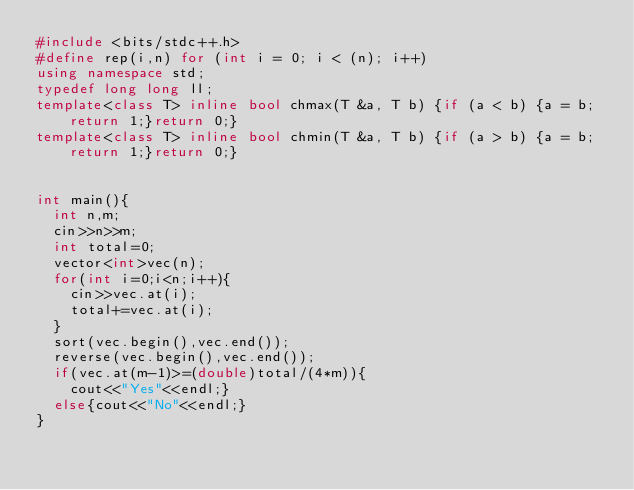Convert code to text. <code><loc_0><loc_0><loc_500><loc_500><_C++_>#include <bits/stdc++.h>
#define rep(i,n) for (int i = 0; i < (n); i++)
using namespace std;
typedef long long ll;
template<class T> inline bool chmax(T &a, T b) {if (a < b) {a = b;return 1;}return 0;}
template<class T> inline bool chmin(T &a, T b) {if (a > b) {a = b;return 1;}return 0;}


int main(){
  int n,m;
  cin>>n>>m;
  int total=0;
  vector<int>vec(n);
  for(int i=0;i<n;i++){
    cin>>vec.at(i);
    total+=vec.at(i);
  }
  sort(vec.begin(),vec.end());
  reverse(vec.begin(),vec.end());
  if(vec.at(m-1)>=(double)total/(4*m)){
    cout<<"Yes"<<endl;}
  else{cout<<"No"<<endl;}
}

</code> 